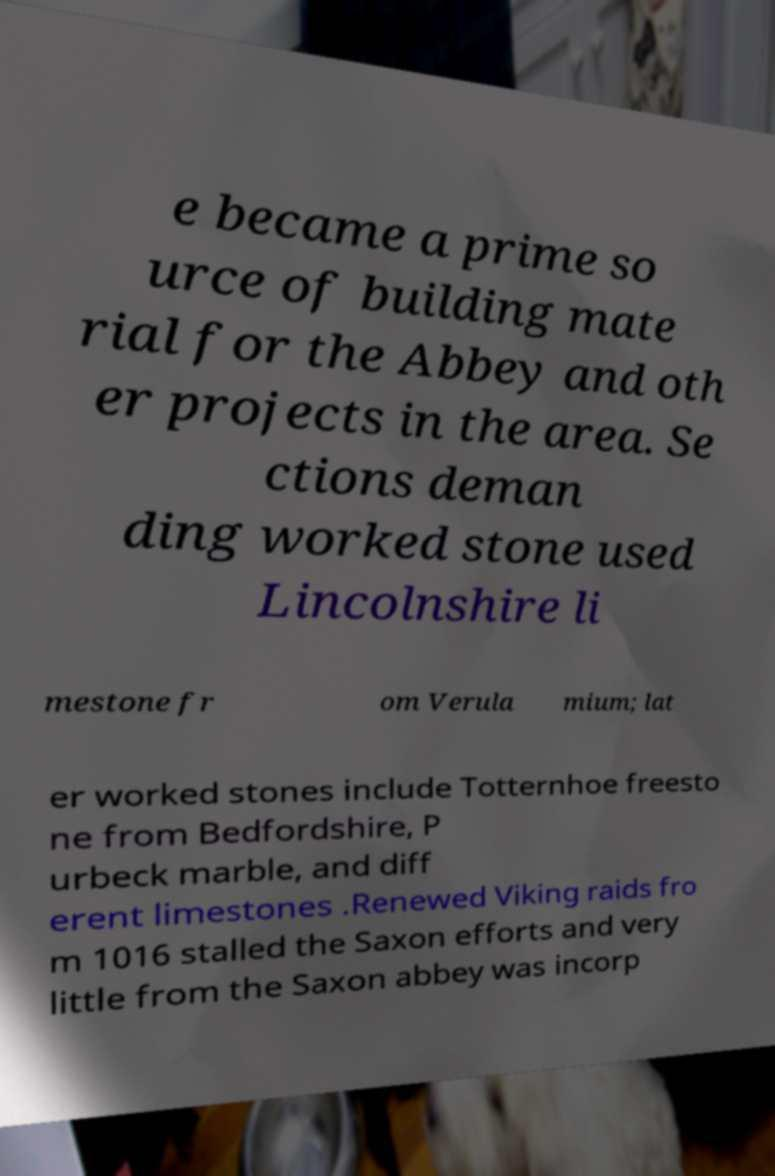For documentation purposes, I need the text within this image transcribed. Could you provide that? e became a prime so urce of building mate rial for the Abbey and oth er projects in the area. Se ctions deman ding worked stone used Lincolnshire li mestone fr om Verula mium; lat er worked stones include Totternhoe freesto ne from Bedfordshire, P urbeck marble, and diff erent limestones .Renewed Viking raids fro m 1016 stalled the Saxon efforts and very little from the Saxon abbey was incorp 